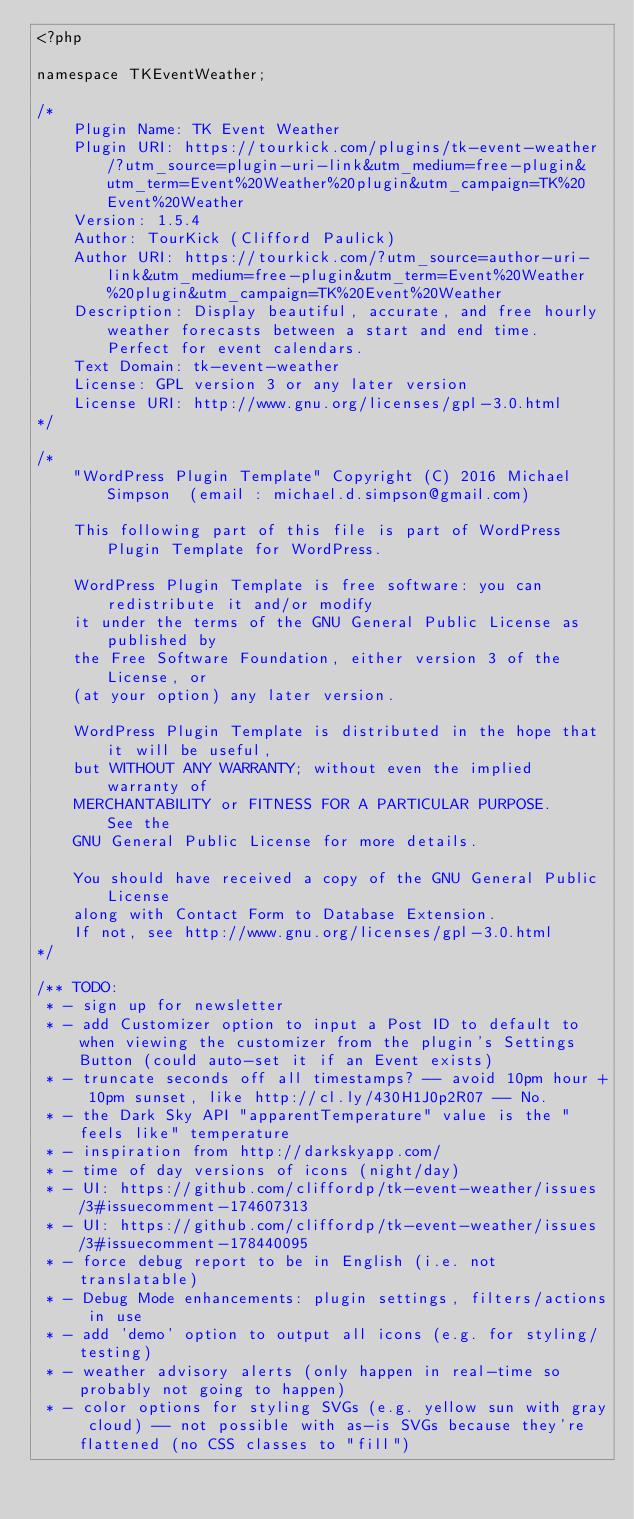<code> <loc_0><loc_0><loc_500><loc_500><_PHP_><?php

namespace TKEventWeather;

/*
	Plugin Name: TK Event Weather
	Plugin URI: https://tourkick.com/plugins/tk-event-weather/?utm_source=plugin-uri-link&utm_medium=free-plugin&utm_term=Event%20Weather%20plugin&utm_campaign=TK%20Event%20Weather
	Version: 1.5.4
	Author: TourKick (Clifford Paulick)
	Author URI: https://tourkick.com/?utm_source=author-uri-link&utm_medium=free-plugin&utm_term=Event%20Weather%20plugin&utm_campaign=TK%20Event%20Weather
	Description: Display beautiful, accurate, and free hourly weather forecasts between a start and end time. Perfect for event calendars.
	Text Domain: tk-event-weather
	License: GPL version 3 or any later version
	License URI: http://www.gnu.org/licenses/gpl-3.0.html
*/

/*
	"WordPress Plugin Template" Copyright (C) 2016 Michael Simpson	(email : michael.d.simpson@gmail.com)

	This following part of this file is part of WordPress Plugin Template for WordPress.

	WordPress Plugin Template is free software: you can redistribute it and/or modify
	it under the terms of the GNU General Public License as published by
	the Free Software Foundation, either version 3 of the License, or
	(at your option) any later version.

	WordPress Plugin Template is distributed in the hope that it will be useful,
	but WITHOUT ANY WARRANTY; without even the implied warranty of
	MERCHANTABILITY or FITNESS FOR A PARTICULAR PURPOSE.	See the
	GNU General Public License for more details.

	You should have received a copy of the GNU General Public License
	along with Contact Form to Database Extension.
	If not, see http://www.gnu.org/licenses/gpl-3.0.html
*/

/** TODO:
 * - sign up for newsletter
 * - add Customizer option to input a Post ID to default to when viewing the customizer from the plugin's Settings Button (could auto-set it if an Event exists)
 * - truncate seconds off all timestamps? -- avoid 10pm hour + 10pm sunset, like http://cl.ly/430H1J0p2R07 -- No.
 * - the Dark Sky API "apparentTemperature" value is the "feels like" temperature
 * - inspiration from http://darkskyapp.com/
 * - time of day versions of icons (night/day)
 * - UI: https://github.com/cliffordp/tk-event-weather/issues/3#issuecomment-174607313
 * - UI: https://github.com/cliffordp/tk-event-weather/issues/3#issuecomment-178440095
 * - force debug report to be in English (i.e. not translatable)
 * - Debug Mode enhancements: plugin settings, filters/actions in use
 * - add 'demo' option to output all icons (e.g. for styling/testing)
 * - weather advisory alerts (only happen in real-time so probably not going to happen)
 * - color options for styling SVGs (e.g. yellow sun with gray cloud) -- not possible with as-is SVGs because they're flattened (no CSS classes to "fill")</code> 